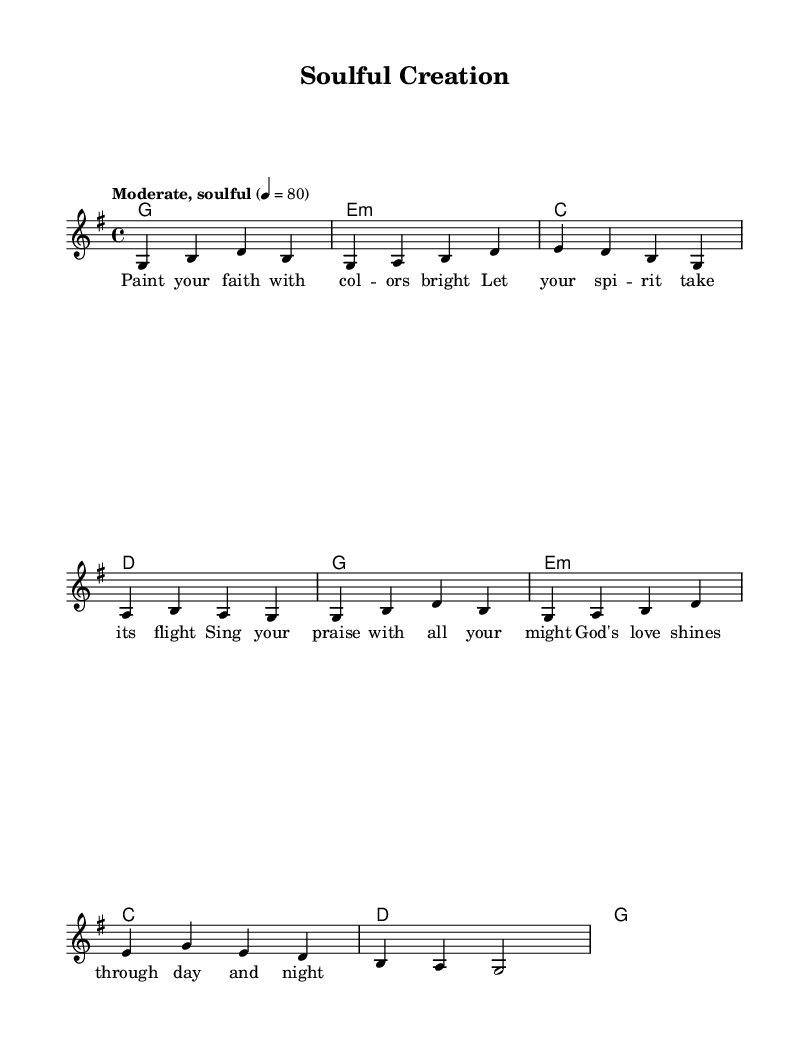What is the key signature of this music? The key signature shows one sharp, indicating that the piece is in G major.
Answer: G major What is the time signature of the piece? The time signature is located at the beginning of the staff and is indicated as 4/4, meaning four beats per measure.
Answer: 4/4 What is the tempo marking for this piece? The tempo marking is written above the melody and indicates "Moderate, soulful" with a metronome marking of 80, suggesting a moderate pace for the piece.
Answer: Moderate, soulful How many measures are in the melody? By counting the groups of notes separated by vertical lines (bars), the total number of measures in the melody appears to be eight.
Answer: Eight What is the first lyric of the verse? The lyrics are placed below the melody notes; the first line reads, "Paint your faith with col -- ors bright."
Answer: Paint your faith with colors bright What harmony is played with the first measure of melody? The first measure of the melody corresponds with a G major chord indicated under it, establishing the harmonic foundation for the melody.
Answer: G major What aspect of faith is celebrated in this song? The lyrics highlight creativity and the expression of faith through art and song, indicating that God's love inspires and uplifts the spirit.
Answer: Creativity and expression of faith 